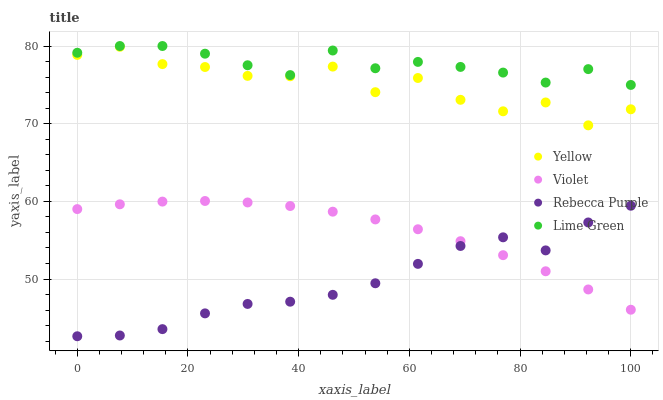Does Rebecca Purple have the minimum area under the curve?
Answer yes or no. Yes. Does Lime Green have the maximum area under the curve?
Answer yes or no. Yes. Does Yellow have the minimum area under the curve?
Answer yes or no. No. Does Yellow have the maximum area under the curve?
Answer yes or no. No. Is Violet the smoothest?
Answer yes or no. Yes. Is Yellow the roughest?
Answer yes or no. Yes. Is Rebecca Purple the smoothest?
Answer yes or no. No. Is Rebecca Purple the roughest?
Answer yes or no. No. Does Rebecca Purple have the lowest value?
Answer yes or no. Yes. Does Yellow have the lowest value?
Answer yes or no. No. Does Lime Green have the highest value?
Answer yes or no. Yes. Does Yellow have the highest value?
Answer yes or no. No. Is Violet less than Yellow?
Answer yes or no. Yes. Is Yellow greater than Violet?
Answer yes or no. Yes. Does Rebecca Purple intersect Violet?
Answer yes or no. Yes. Is Rebecca Purple less than Violet?
Answer yes or no. No. Is Rebecca Purple greater than Violet?
Answer yes or no. No. Does Violet intersect Yellow?
Answer yes or no. No. 